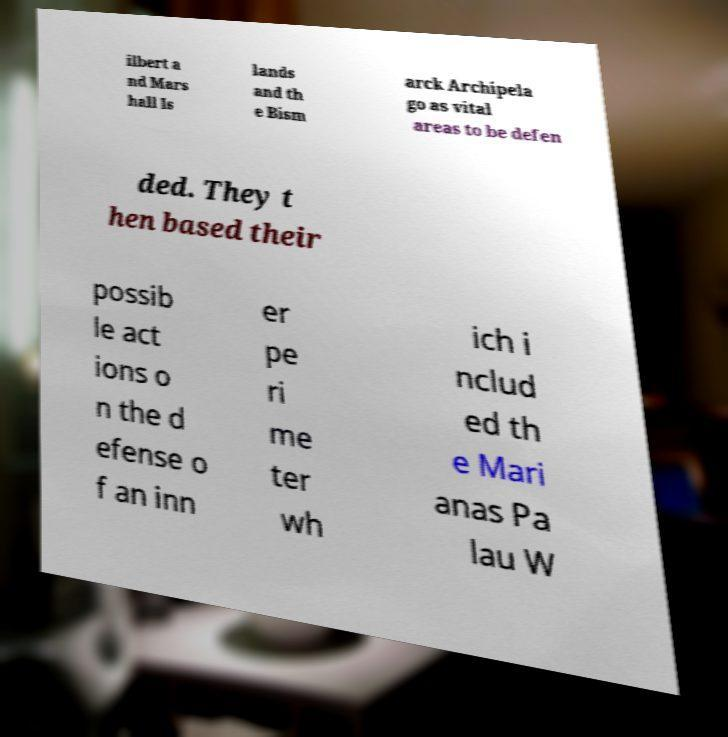Please identify and transcribe the text found in this image. ilbert a nd Mars hall Is lands and th e Bism arck Archipela go as vital areas to be defen ded. They t hen based their possib le act ions o n the d efense o f an inn er pe ri me ter wh ich i nclud ed th e Mari anas Pa lau W 